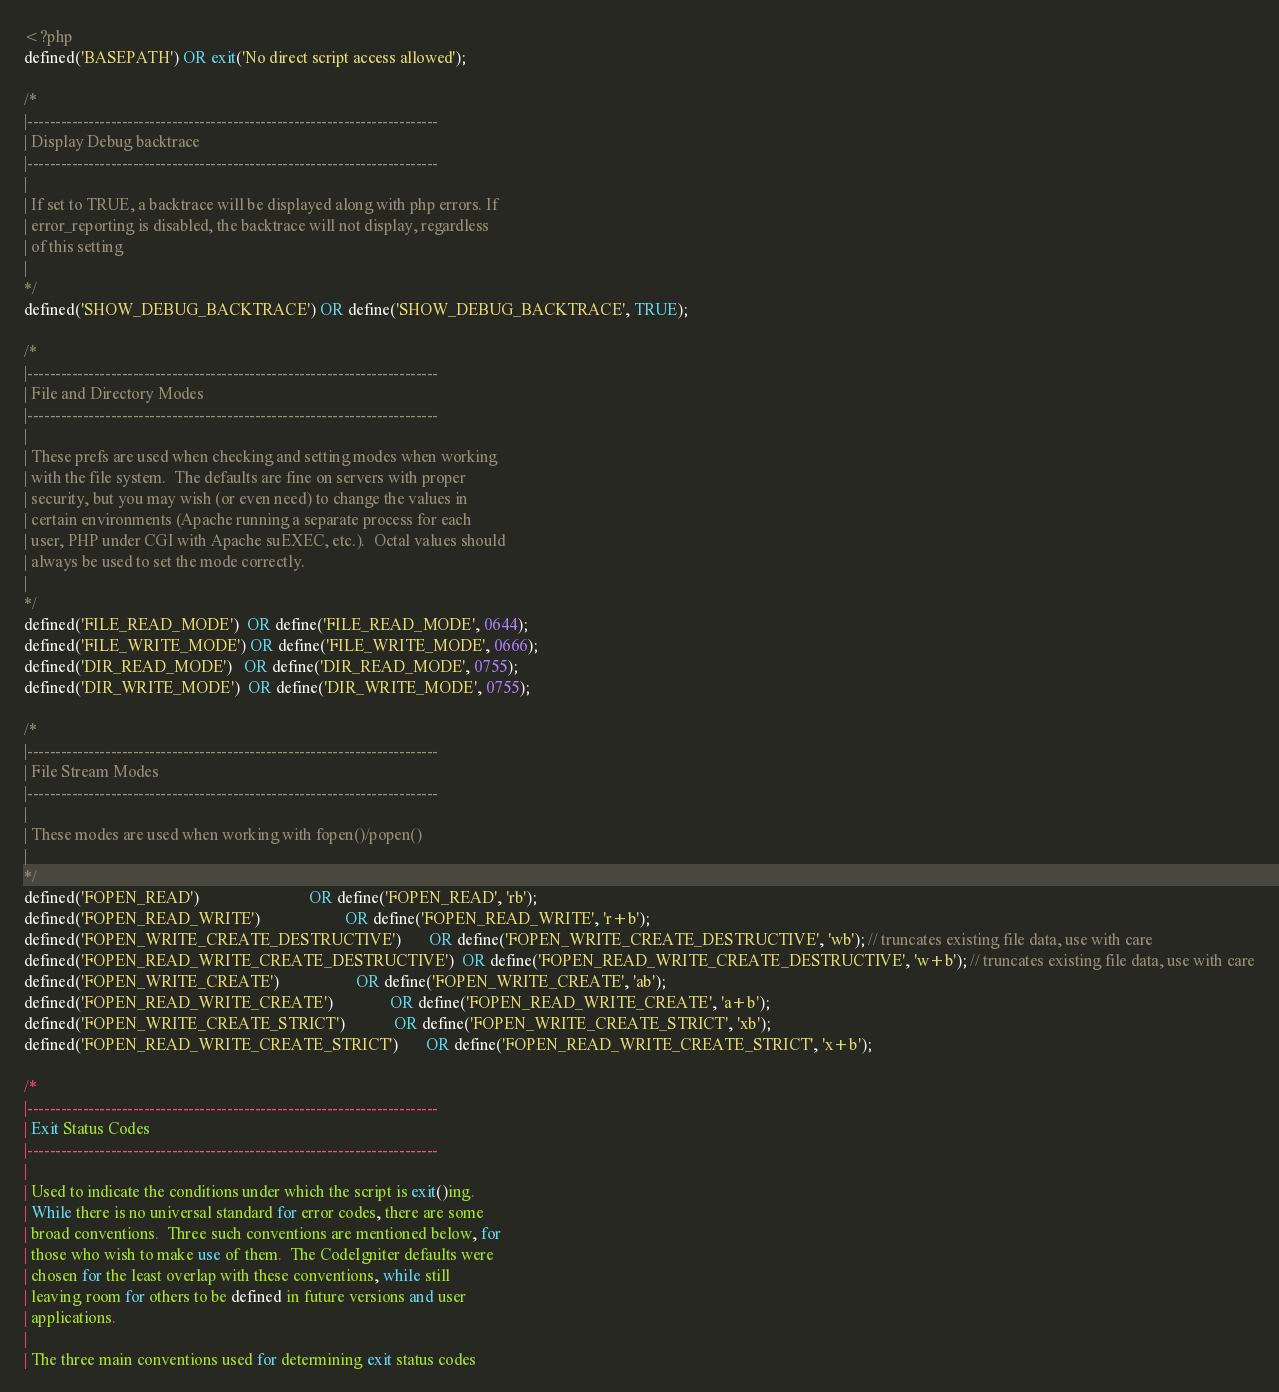<code> <loc_0><loc_0><loc_500><loc_500><_PHP_><?php
defined('BASEPATH') OR exit('No direct script access allowed');

/*
|--------------------------------------------------------------------------
| Display Debug backtrace
|--------------------------------------------------------------------------
|
| If set to TRUE, a backtrace will be displayed along with php errors. If
| error_reporting is disabled, the backtrace will not display, regardless
| of this setting
|
*/
defined('SHOW_DEBUG_BACKTRACE') OR define('SHOW_DEBUG_BACKTRACE', TRUE);

/*
|--------------------------------------------------------------------------
| File and Directory Modes
|--------------------------------------------------------------------------
|
| These prefs are used when checking and setting modes when working
| with the file system.  The defaults are fine on servers with proper
| security, but you may wish (or even need) to change the values in
| certain environments (Apache running a separate process for each
| user, PHP under CGI with Apache suEXEC, etc.).  Octal values should
| always be used to set the mode correctly.
|
*/
defined('FILE_READ_MODE')  OR define('FILE_READ_MODE', 0644);
defined('FILE_WRITE_MODE') OR define('FILE_WRITE_MODE', 0666);
defined('DIR_READ_MODE')   OR define('DIR_READ_MODE', 0755);
defined('DIR_WRITE_MODE')  OR define('DIR_WRITE_MODE', 0755);

/*
|--------------------------------------------------------------------------
| File Stream Modes
|--------------------------------------------------------------------------
|
| These modes are used when working with fopen()/popen()
|
*/
defined('FOPEN_READ')                           OR define('FOPEN_READ', 'rb');
defined('FOPEN_READ_WRITE')                     OR define('FOPEN_READ_WRITE', 'r+b');
defined('FOPEN_WRITE_CREATE_DESTRUCTIVE')       OR define('FOPEN_WRITE_CREATE_DESTRUCTIVE', 'wb'); // truncates existing file data, use with care
defined('FOPEN_READ_WRITE_CREATE_DESTRUCTIVE')  OR define('FOPEN_READ_WRITE_CREATE_DESTRUCTIVE', 'w+b'); // truncates existing file data, use with care
defined('FOPEN_WRITE_CREATE')                   OR define('FOPEN_WRITE_CREATE', 'ab');
defined('FOPEN_READ_WRITE_CREATE')              OR define('FOPEN_READ_WRITE_CREATE', 'a+b');
defined('FOPEN_WRITE_CREATE_STRICT')            OR define('FOPEN_WRITE_CREATE_STRICT', 'xb');
defined('FOPEN_READ_WRITE_CREATE_STRICT')       OR define('FOPEN_READ_WRITE_CREATE_STRICT', 'x+b');

/*
|--------------------------------------------------------------------------
| Exit Status Codes
|--------------------------------------------------------------------------
|
| Used to indicate the conditions under which the script is exit()ing.
| While there is no universal standard for error codes, there are some
| broad conventions.  Three such conventions are mentioned below, for
| those who wish to make use of them.  The CodeIgniter defaults were
| chosen for the least overlap with these conventions, while still
| leaving room for others to be defined in future versions and user
| applications.
|
| The three main conventions used for determining exit status codes</code> 